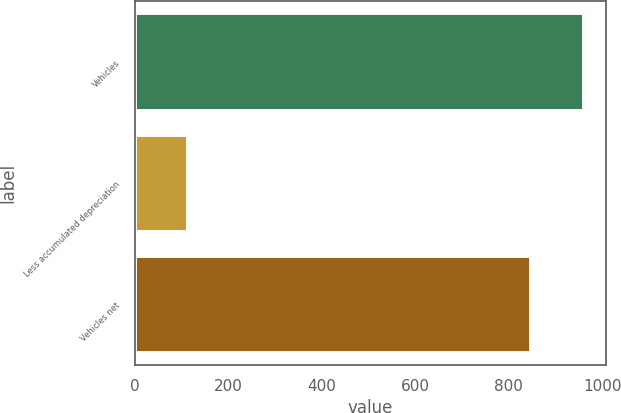<chart> <loc_0><loc_0><loc_500><loc_500><bar_chart><fcel>Vehicles<fcel>Less accumulated depreciation<fcel>Vehicles net<nl><fcel>960<fcel>113<fcel>847<nl></chart> 